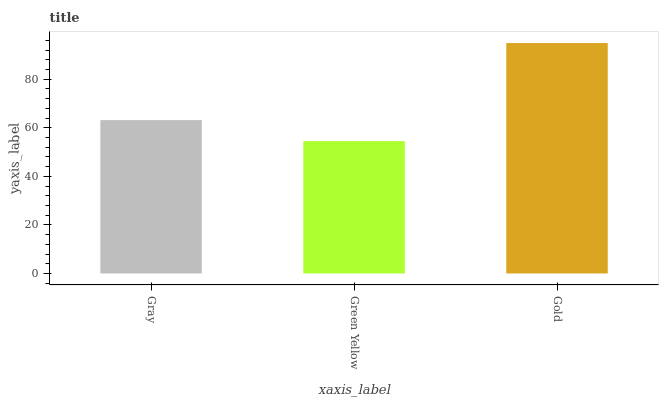Is Green Yellow the minimum?
Answer yes or no. Yes. Is Gold the maximum?
Answer yes or no. Yes. Is Gold the minimum?
Answer yes or no. No. Is Green Yellow the maximum?
Answer yes or no. No. Is Gold greater than Green Yellow?
Answer yes or no. Yes. Is Green Yellow less than Gold?
Answer yes or no. Yes. Is Green Yellow greater than Gold?
Answer yes or no. No. Is Gold less than Green Yellow?
Answer yes or no. No. Is Gray the high median?
Answer yes or no. Yes. Is Gray the low median?
Answer yes or no. Yes. Is Gold the high median?
Answer yes or no. No. Is Gold the low median?
Answer yes or no. No. 